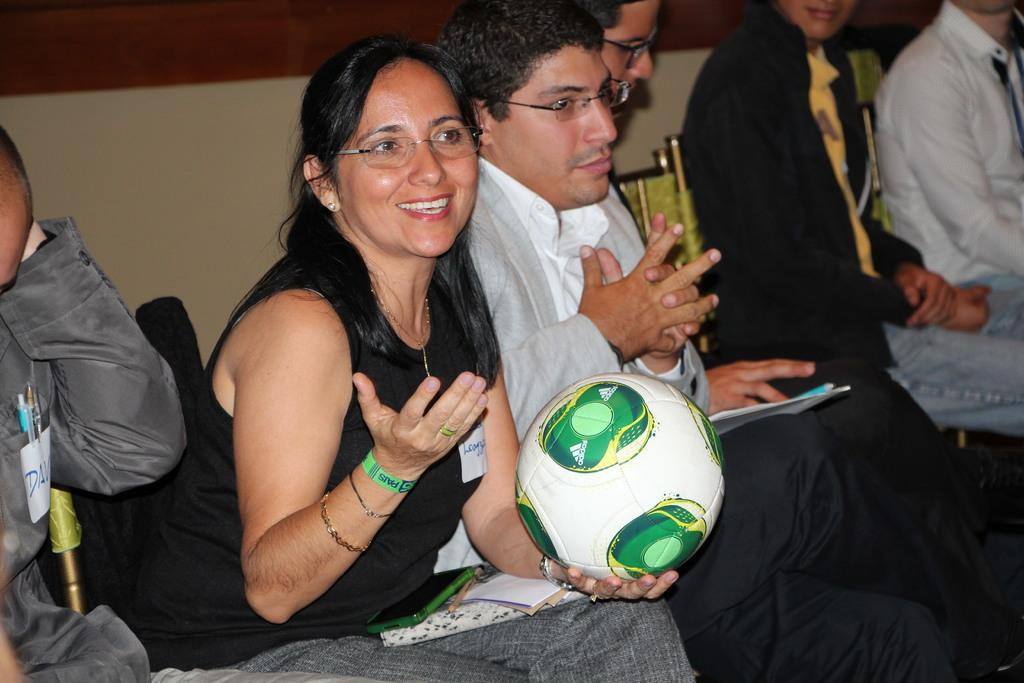What are the people in the image doing? The people in the image are sitting on chairs. Can you describe the woman among them? A woman is sitting among them, and she is holding a ball in her hand. What type of stone can be seen in the woman's hand in the image? There is no stone present in the image; the woman is holding a ball. Can you describe the horse that is standing next to the woman in the image? There is no horse present in the image; the woman is sitting among people who are sitting on chairs. 